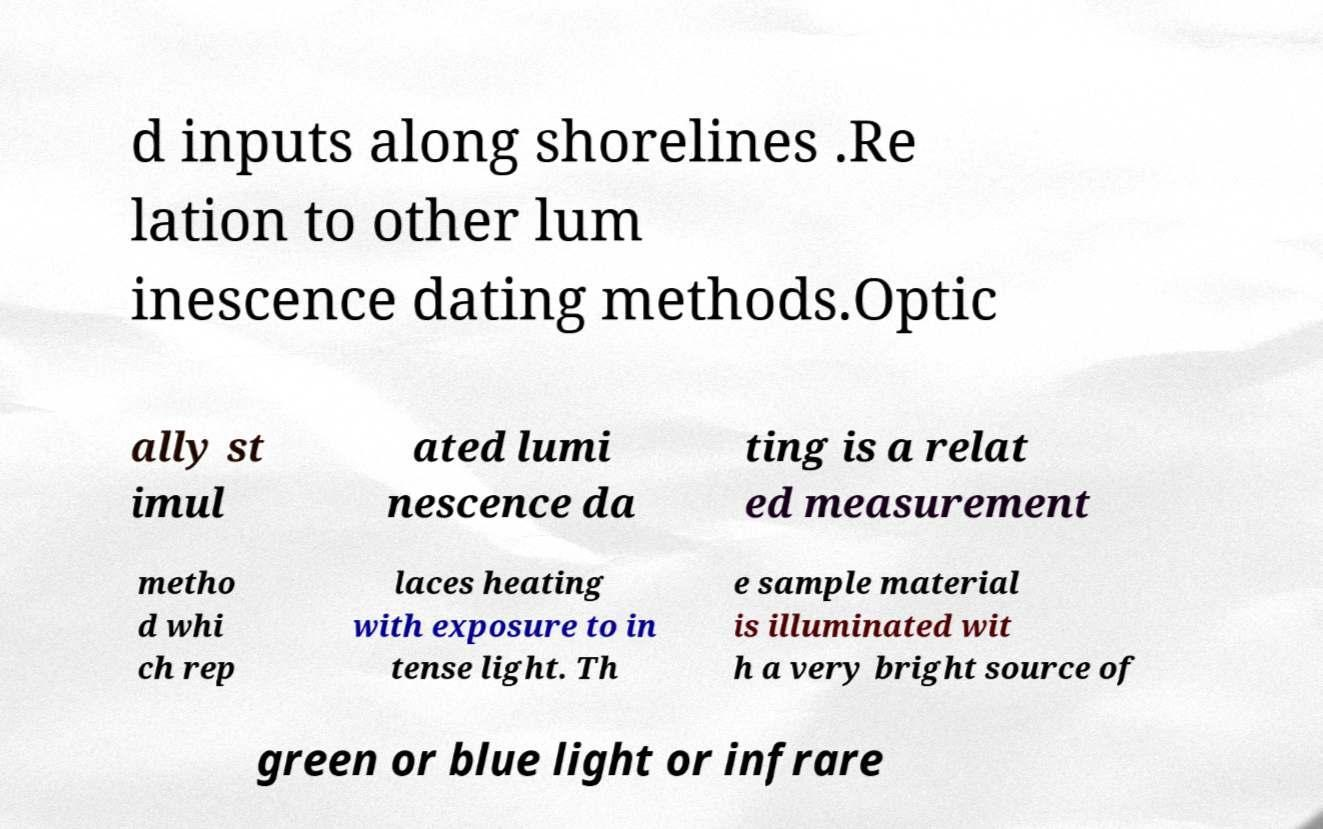Could you assist in decoding the text presented in this image and type it out clearly? d inputs along shorelines .Re lation to other lum inescence dating methods.Optic ally st imul ated lumi nescence da ting is a relat ed measurement metho d whi ch rep laces heating with exposure to in tense light. Th e sample material is illuminated wit h a very bright source of green or blue light or infrare 